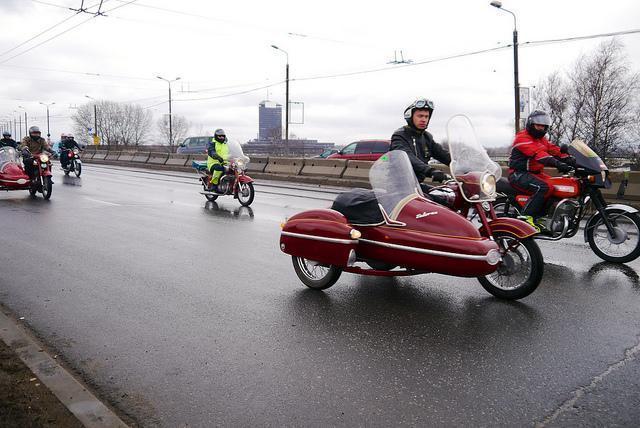What could have made the road appear shiny?
Make your selection and explain in format: 'Answer: answer
Rationale: rationale.'
Options: Wind, rain, snow, paint. Answer: rain.
Rationale: A road is shiny and the sky is overcast. roads look shiny when they are wet. 